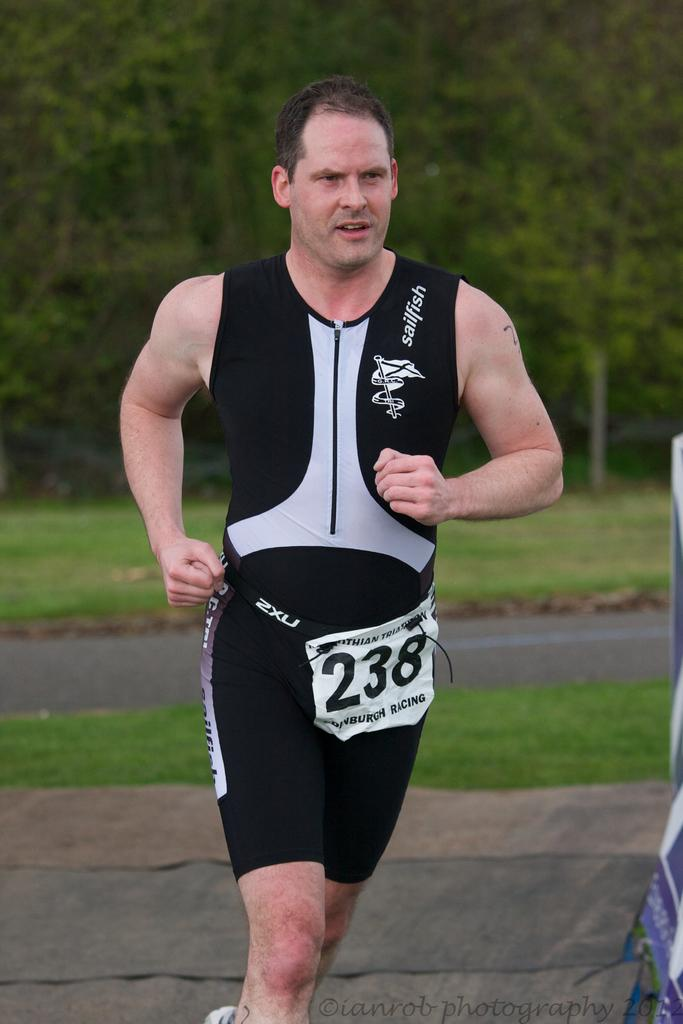<image>
Give a short and clear explanation of the subsequent image. Runner 238 is wearing a tight black outfit. 